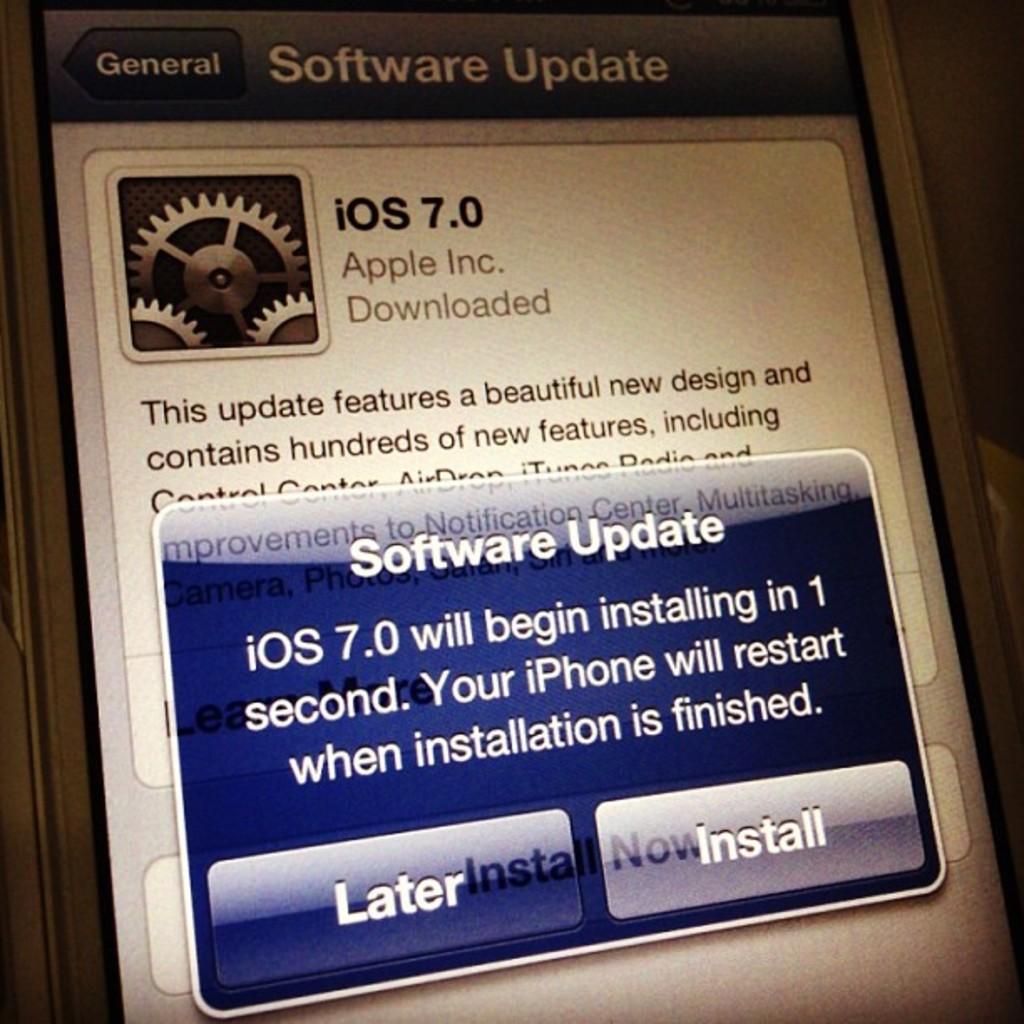What will happen when the software installation is finished?
Your answer should be very brief. Iphone will restart. What type of phone is this?
Make the answer very short. Iphone. 